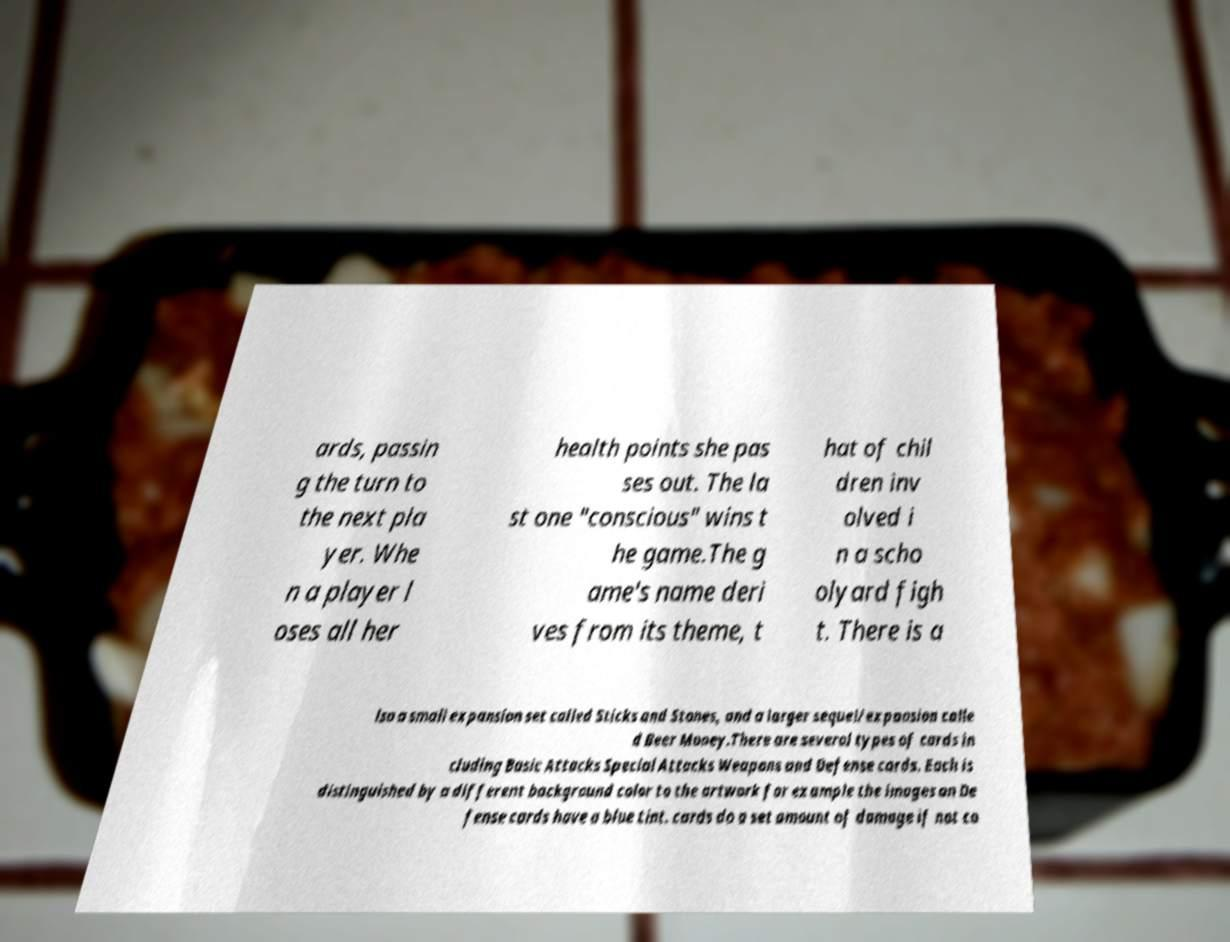What messages or text are displayed in this image? I need them in a readable, typed format. ards, passin g the turn to the next pla yer. Whe n a player l oses all her health points she pas ses out. The la st one "conscious" wins t he game.The g ame's name deri ves from its theme, t hat of chil dren inv olved i n a scho olyard figh t. There is a lso a small expansion set called Sticks and Stones, and a larger sequel/expansion calle d Beer Money.There are several types of cards in cluding Basic Attacks Special Attacks Weapons and Defense cards. Each is distinguished by a different background color to the artwork for example the images on De fense cards have a blue tint. cards do a set amount of damage if not co 